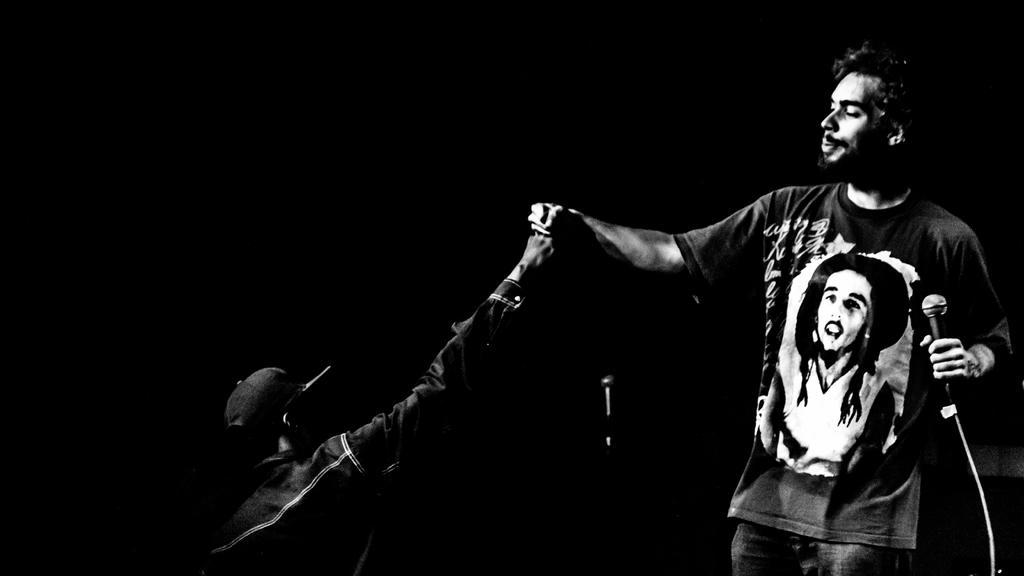In one or two sentences, can you explain what this image depicts? In the image in the center we can see two persons were standing and they were holding their hands. And the right side person is holding a microphone and the left side person is wearing a cap. 